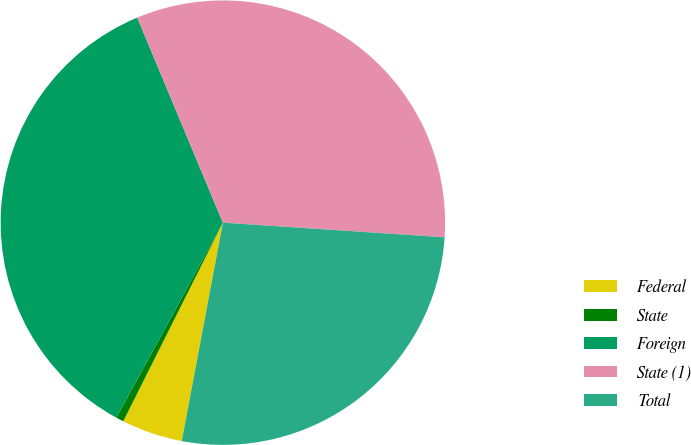<chart> <loc_0><loc_0><loc_500><loc_500><pie_chart><fcel>Federal<fcel>State<fcel>Foreign<fcel>State (1)<fcel>Total<nl><fcel>4.44%<fcel>0.56%<fcel>35.74%<fcel>32.35%<fcel>26.91%<nl></chart> 